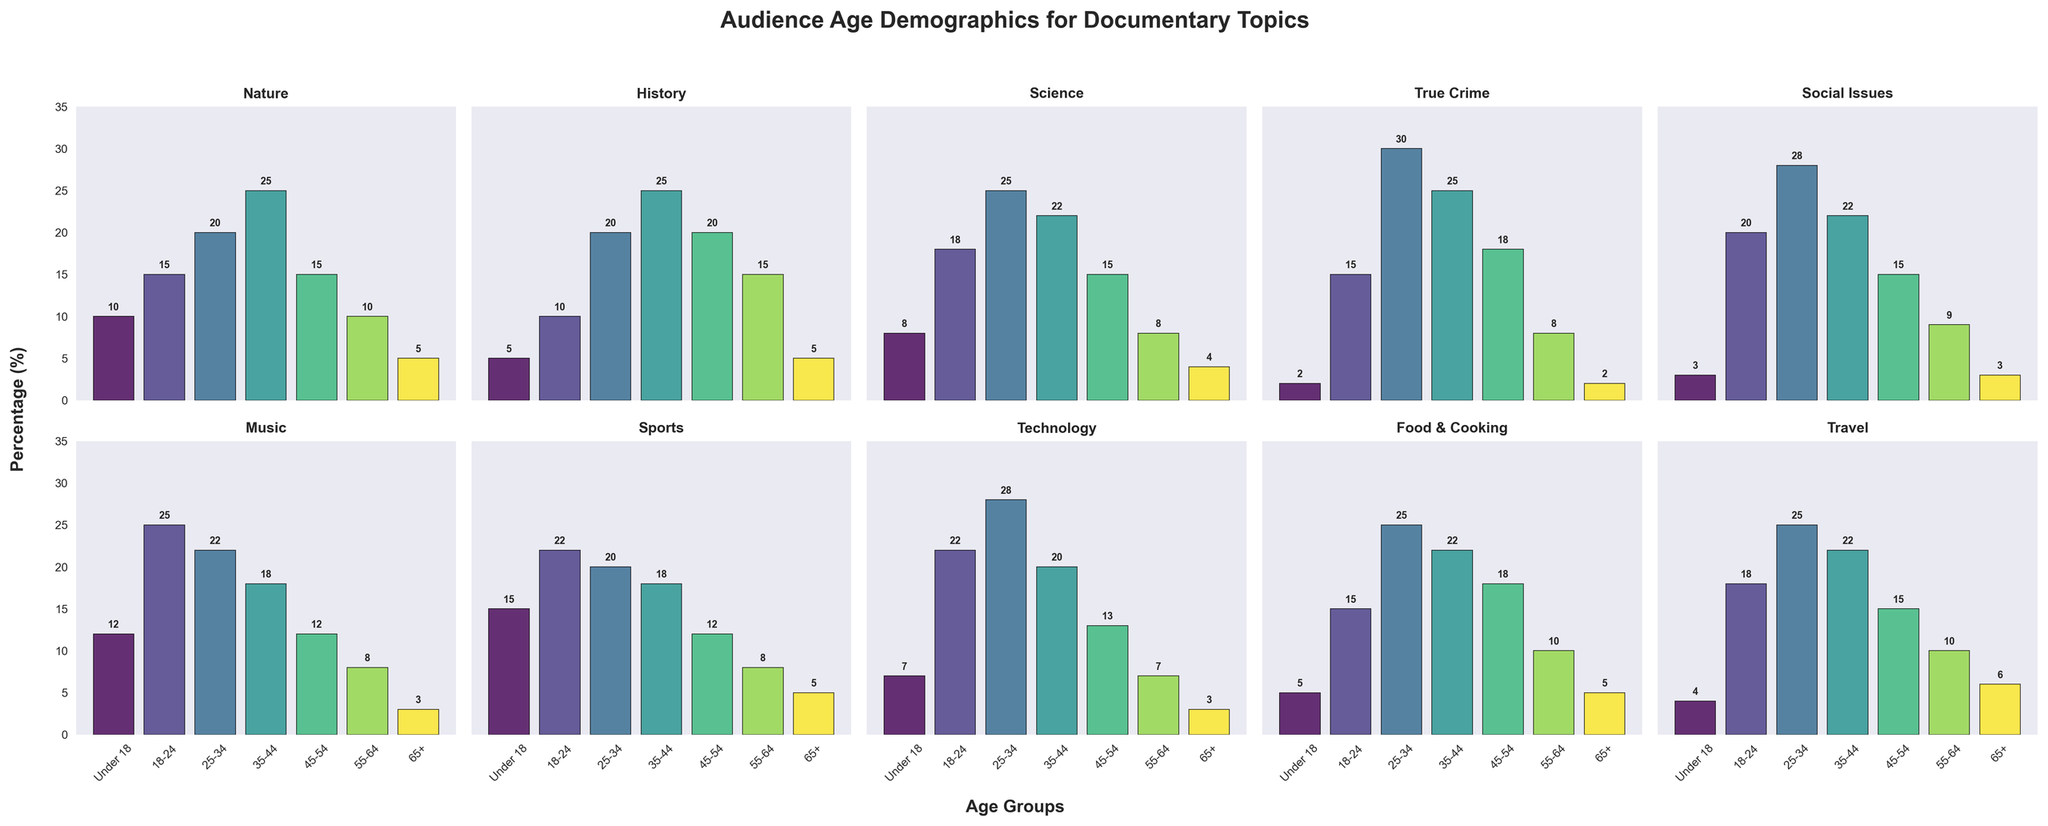What's the total percentage of the audience aged 18-24 and 25-34 for the topic 'Technology'? Add the percentages for the 18-24 and 25-34 age categories for the 'Technology' topic. It's 22% for 18-24 and 28% for 25-34. So, 22 + 28 = 50.
Answer: 50 Which documentary topic has the highest percentage of audience under 18? Look at the bar heights in the 'Under 18' category across all topics. The highest bar is for 'Sports' at 15%.
Answer: Sports For the 'History' topic, which age group shows the second highest percentage? Examine the bar heights for each age group within the 'History' subplot. The highest is '35-44' at 25%, and the second highest is '45-54' at 20%.
Answer: 45-54 Which two documentary topics have an equal percentage of audience aged 65+? Compare the bar heights in the '65+' category for each topic. Both 'Nature' and 'Food & Cooking' have 5%.
Answer: Nature and Food & Cooking Compare the percentage of the '25-34' age group for 'True Crime' and 'Social Issues'. Which one is higher? Look at the bars for the '25-34' age group in both 'True Crime' and 'Social Issues'. For 'True Crime' it's 30%, and for 'Social Issues' it's 28%.
Answer: True Crime What is the average percentage of audiences aged 35-44 across all topics? Sum the percentages of the '35-44' age group for all topics and divide by the number of topics. That is (25 (Nature) + 25 (History) + 22 (Science) + 25 (True Crime) + 22 (Social Issues) + 18 (Music) + 18 (Sports) + 20 (Technology) + 22 (Food & Cooking) + 22 (Travel)) / 10 = 21.9%.
Answer: 21.9 In the 'Music' topic, which age group has the lowest audience percentage and how much is it? Look at the bar heights in the 'Music' subplot and identify the smallest bar. The lowest percentage is 3% for the '65+' age group.
Answer: 65+, 3 What's the difference in audience percentage between the '18-24' and '55-64' age groups for the 'Sports' topic? Find the values for both age groups in the 'Sports' subplot. It's 22% for 18-24 and 8% for 55-64. The difference is 22 - 8 = 14.
Answer: 14 What's the total percentage of the audience in the '55-64' age group for ‘Nature’, ‘History’, and ‘Science’ topics combined? Add the percentages for the '55-64' age group in these topics. It's 10% for Nature, 15% for History, and 8% for Science. So, 10 + 15 + 8 = 33%.
Answer: 33 Which documentary topic has the smallest range of audience percentages across all age groups? Calculate the range (difference between the highest and lowest values) for each topic. 'Travel' has the smallest range: (25 (maximum) - 4 (minimum)) = 21%.
Answer: Travel 